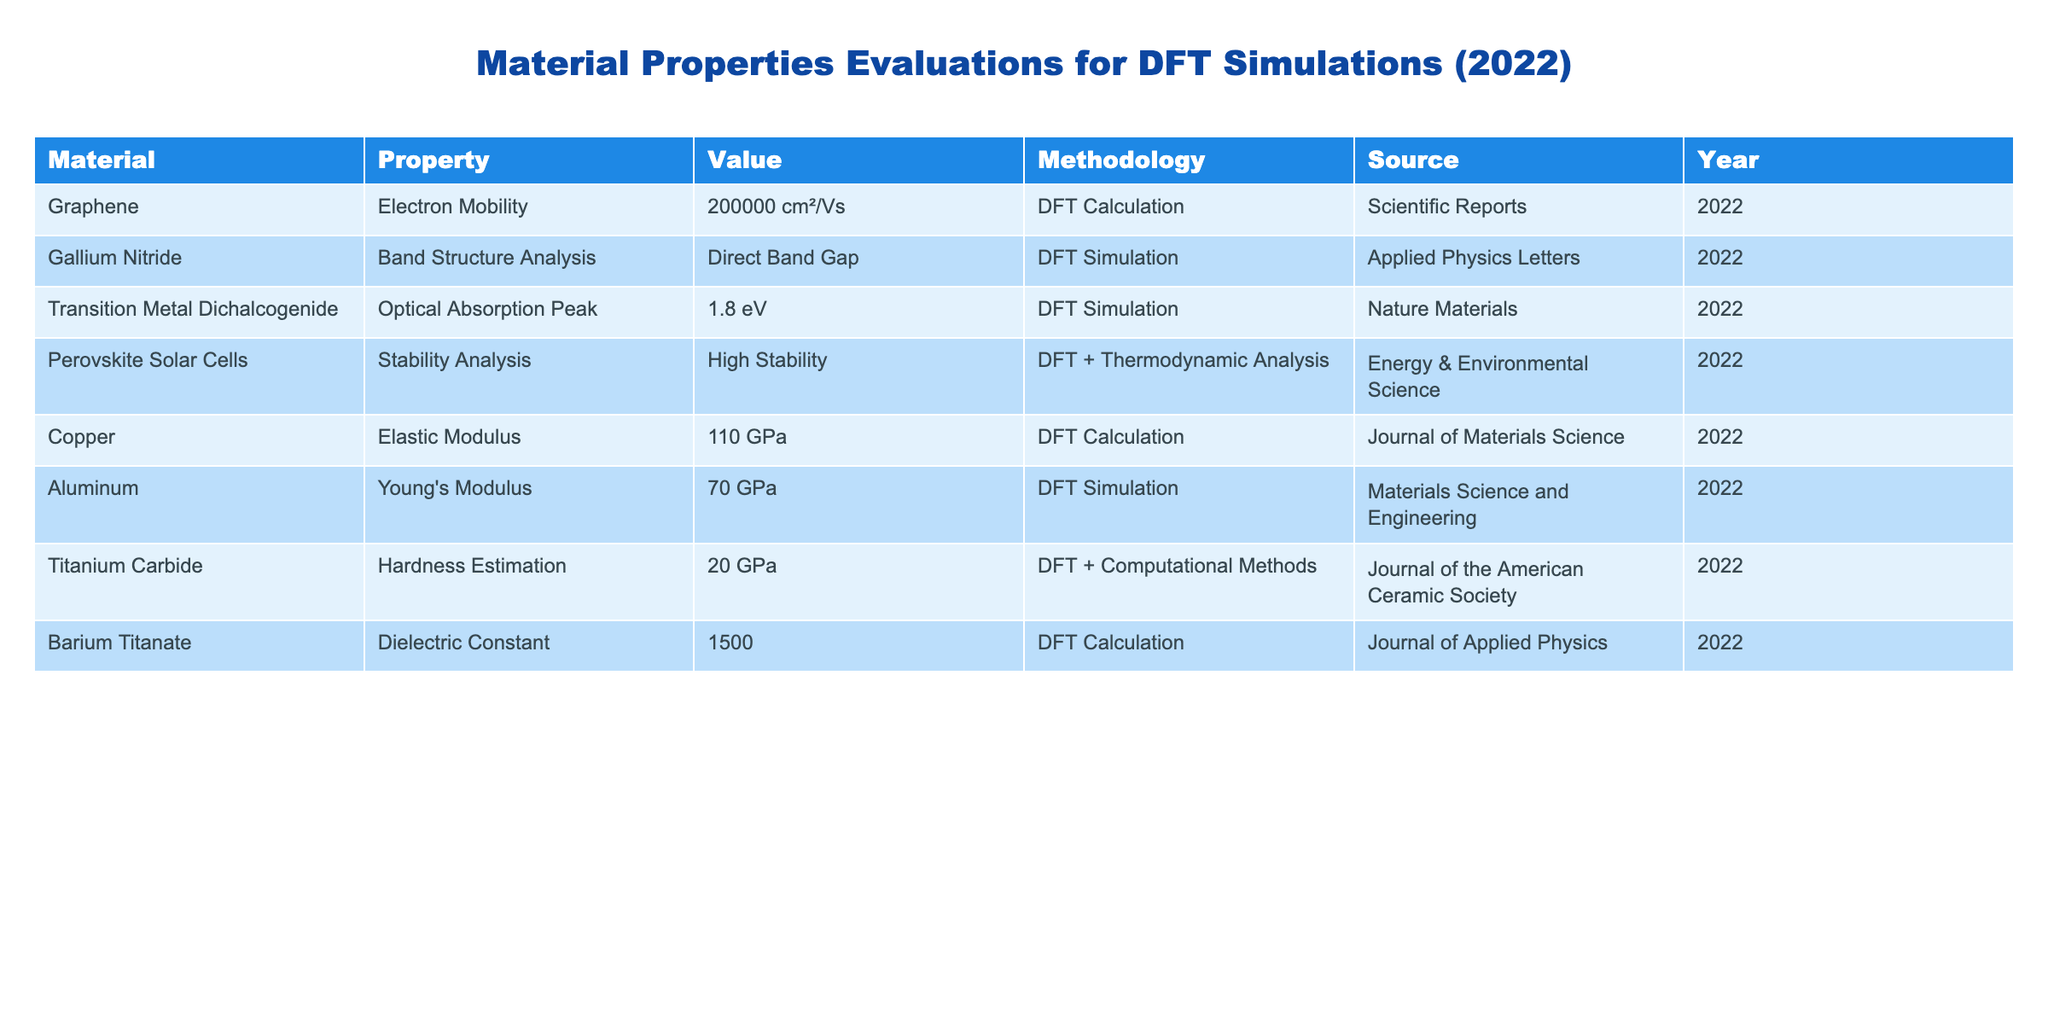What is the electron mobility of graphene? The value for electron mobility of graphene is directly listed in the table under the corresponding material, which is 200000 cm²/Vs.
Answer: 200000 cm²/Vs Which material has the highest Young's modulus according to the table? The table lists Young's modulus for Aluminum as 70 GPa and does not provide a higher value for any other material listed. Therefore, Aluminum has the highest Young's modulus.
Answer: Aluminum What is the difference in elastic modulus between Copper and Titanium Carbide? The elastic modulus for Copper is given as 110 GPa, while for Titanium Carbide it is 20 GPa. The difference is calculated as 110 GPa - 20 GPa = 90 GPa.
Answer: 90 GPa Is the optical absorption peak for Transition Metal Dichalcogenide equal to or greater than 2 eV? The table lists the optical absorption peak for Transition Metal Dichalcogenide as 1.8 eV, which is below 2 eV, making the statement false.
Answer: False What is the average dielectric constant of the materials listed in the table? There is only one material with a dielectric constant listed, which is Barium Titanate with a value of 1500. Since there's only one data point, the average is simply this value, 1500.
Answer: 1500 Which methodology is used for evaluating the stability of Perovskite Solar Cells? The methodology used according to the table is "DFT + Thermodynamic Analysis," which can be confirmed directly from the corresponding row.
Answer: DFT + Thermodynamic Analysis How many materials listed have undergone DFT Calculations? By filtering through the table, we count the rows where the methodology is "DFT Calculation," which occurs for Graphene, Copper, and Barium Titanate. Therefore, three materials have undergone this evaluation.
Answer: 3 Is there any material in the table that has a reported stability analysis? Yes, the table confirms that Perovskite Solar Cells have a stability analysis with a reported result of "High Stability."
Answer: Yes What percentage of the materials listed have a band structure analysis? There is one material, Gallium Nitride that has a band structure analysis out of a total of 8 materials listed. The percentage is calculated as (1/8) * 100 = 12.5%.
Answer: 12.5% 